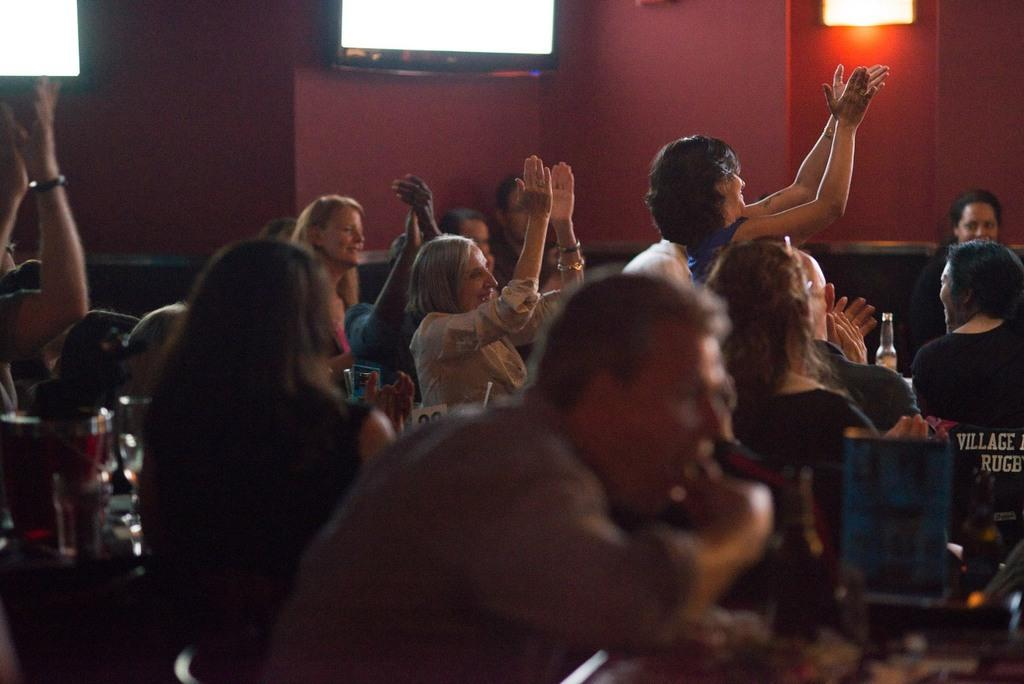How many people are in the image? There is a group of persons in the image. What are the persons in the image doing? The persons are sitting. Where are the persons located in the image? The group of persons is located at the bottom of the image. What can be seen in the background of the image? There is a wall in the background of the image. What type of wealth is visible in the image? There is no wealth visible in the image; it features a group of persons sitting at the bottom of the image with a wall in the background. 